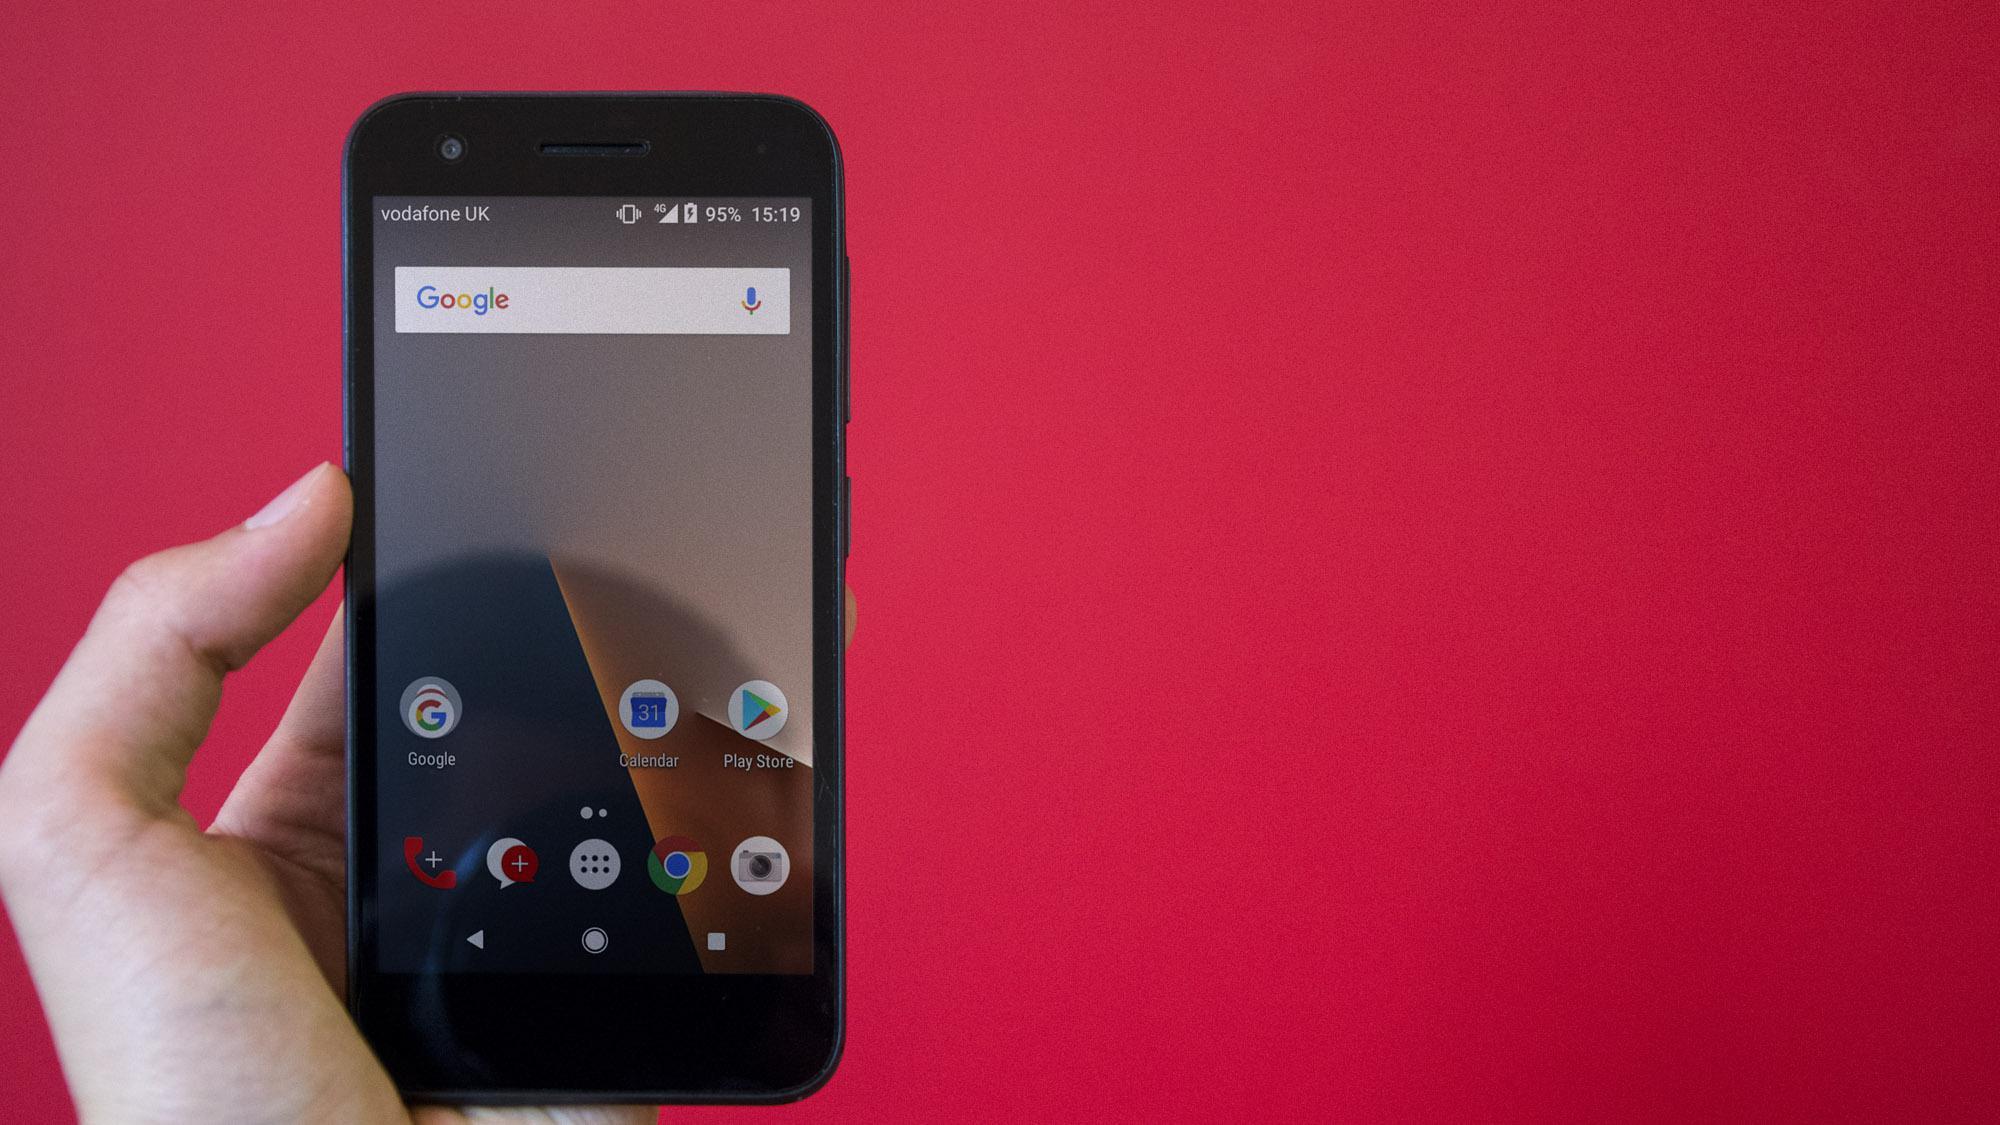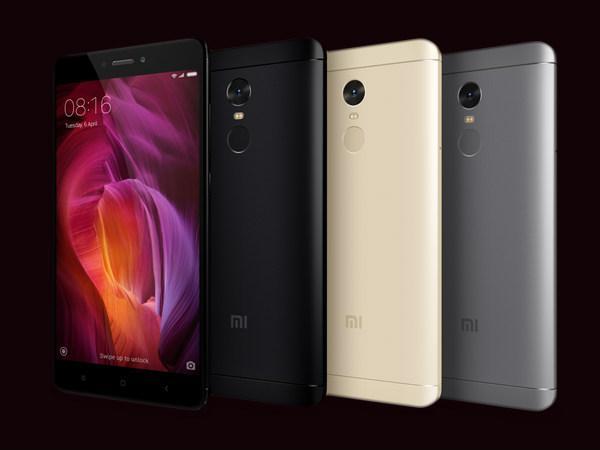The first image is the image on the left, the second image is the image on the right. Evaluate the accuracy of this statement regarding the images: "One image contains exactly four phones, and the other image contains at least five phones.". Is it true? Answer yes or no. No. The first image is the image on the left, the second image is the image on the right. Analyze the images presented: Is the assertion "Every image shows at least four devices and all screens show an image." valid? Answer yes or no. No. 